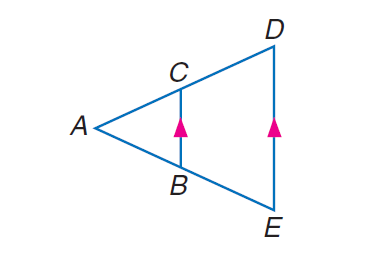Answer the mathemtical geometry problem and directly provide the correct option letter.
Question: Find A C if A C = x - 3, B E = 20, A B = 16, and C D = x + 5.
Choices: A: 32 B: 35 C: 36 D: 40 A 